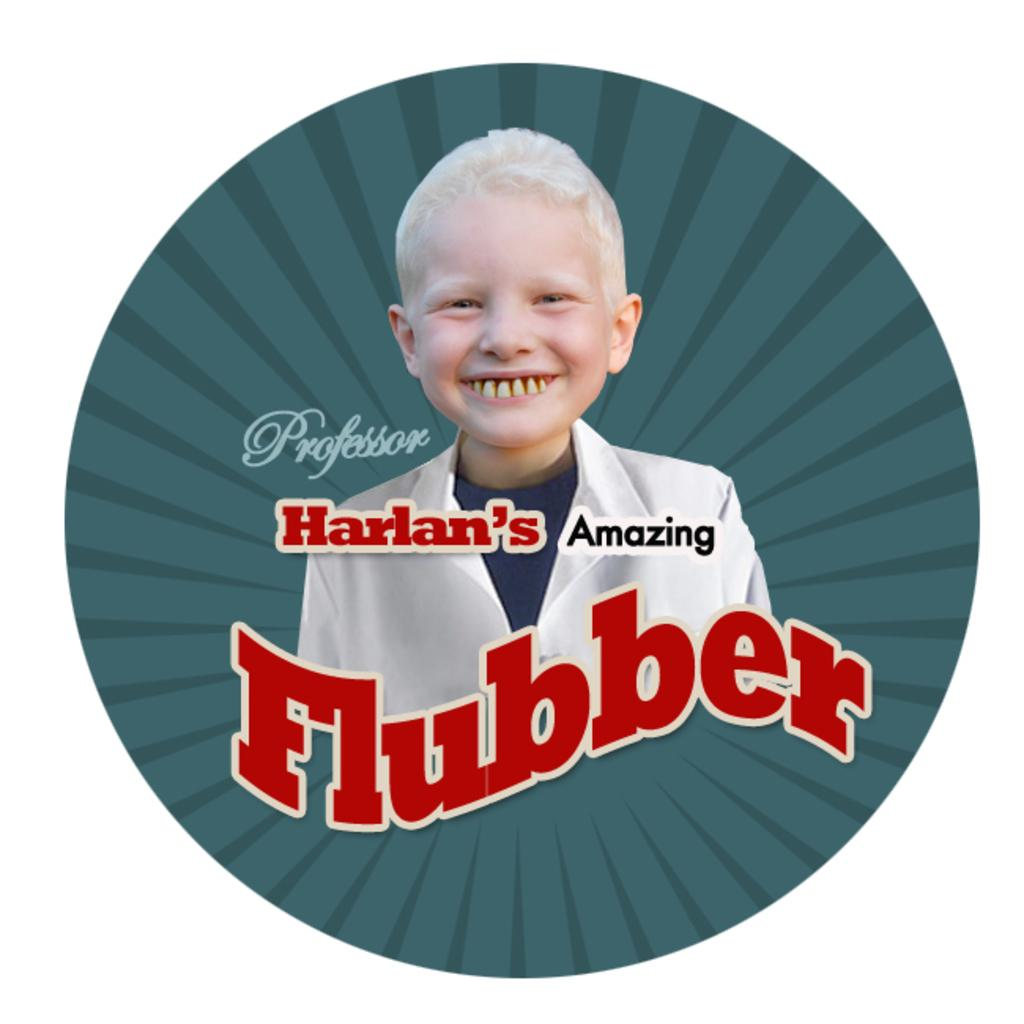Provide a one-sentence caption for the provided image. A picture of a smiling child in with the words Professor Harlan's Amazing Flubber on it. 